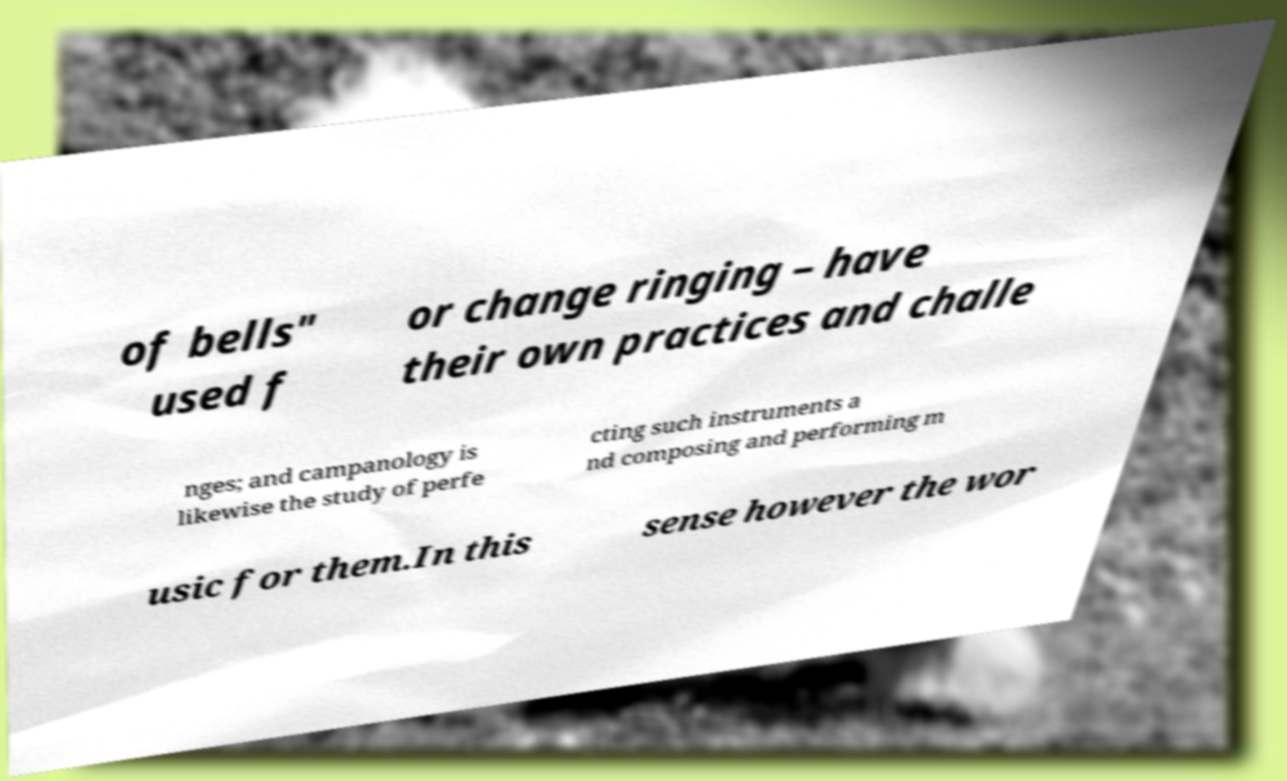Could you assist in decoding the text presented in this image and type it out clearly? of bells" used f or change ringing – have their own practices and challe nges; and campanology is likewise the study of perfe cting such instruments a nd composing and performing m usic for them.In this sense however the wor 